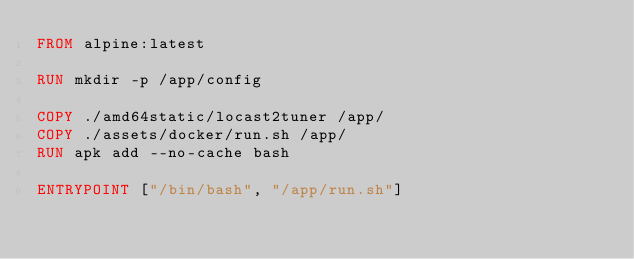<code> <loc_0><loc_0><loc_500><loc_500><_Dockerfile_>FROM alpine:latest

RUN mkdir -p /app/config

COPY ./amd64static/locast2tuner /app/
COPY ./assets/docker/run.sh /app/
RUN apk add --no-cache bash

ENTRYPOINT ["/bin/bash", "/app/run.sh"]
</code> 